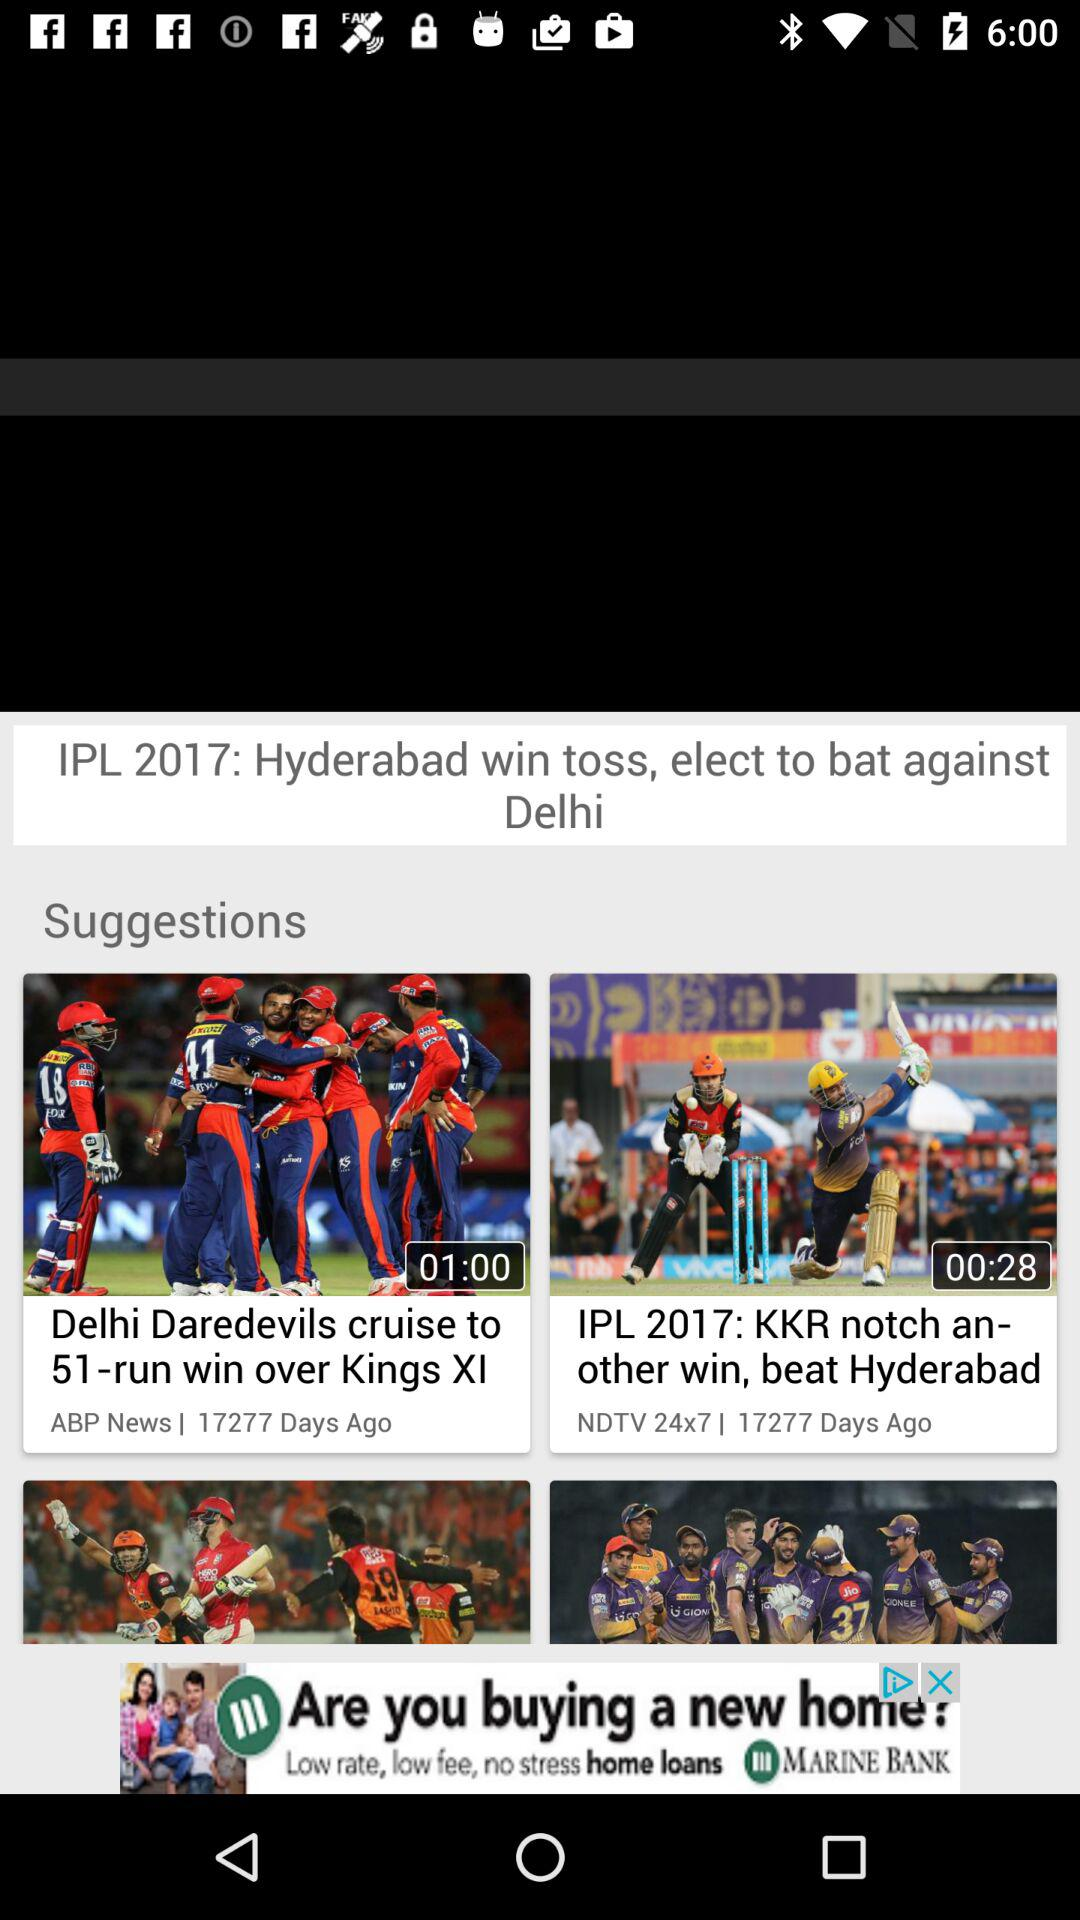Who published this news?
When the provided information is insufficient, respond with <no answer>. <no answer> 